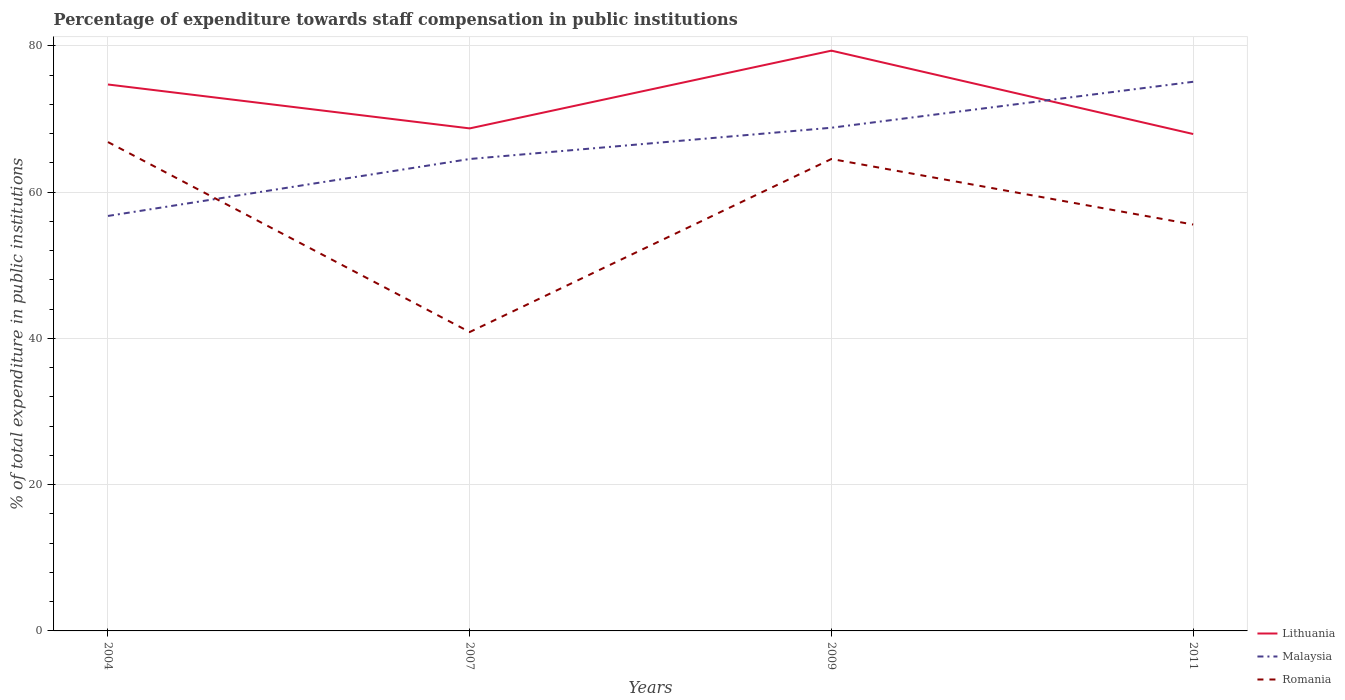How many different coloured lines are there?
Provide a succinct answer. 3. Does the line corresponding to Malaysia intersect with the line corresponding to Romania?
Ensure brevity in your answer.  Yes. Across all years, what is the maximum percentage of expenditure towards staff compensation in Malaysia?
Your answer should be very brief. 56.75. In which year was the percentage of expenditure towards staff compensation in Malaysia maximum?
Make the answer very short. 2004. What is the total percentage of expenditure towards staff compensation in Lithuania in the graph?
Offer a very short reply. -10.63. What is the difference between the highest and the second highest percentage of expenditure towards staff compensation in Lithuania?
Make the answer very short. 11.4. Is the percentage of expenditure towards staff compensation in Romania strictly greater than the percentage of expenditure towards staff compensation in Malaysia over the years?
Your answer should be very brief. No. How many lines are there?
Give a very brief answer. 3. Does the graph contain any zero values?
Make the answer very short. No. How many legend labels are there?
Your answer should be very brief. 3. What is the title of the graph?
Make the answer very short. Percentage of expenditure towards staff compensation in public institutions. What is the label or title of the X-axis?
Your answer should be very brief. Years. What is the label or title of the Y-axis?
Ensure brevity in your answer.  % of total expenditure in public institutions. What is the % of total expenditure in public institutions of Lithuania in 2004?
Your answer should be very brief. 74.73. What is the % of total expenditure in public institutions of Malaysia in 2004?
Ensure brevity in your answer.  56.75. What is the % of total expenditure in public institutions of Romania in 2004?
Make the answer very short. 66.86. What is the % of total expenditure in public institutions in Lithuania in 2007?
Your answer should be compact. 68.72. What is the % of total expenditure in public institutions of Malaysia in 2007?
Offer a very short reply. 64.54. What is the % of total expenditure in public institutions of Romania in 2007?
Keep it short and to the point. 40.88. What is the % of total expenditure in public institutions in Lithuania in 2009?
Give a very brief answer. 79.36. What is the % of total expenditure in public institutions of Malaysia in 2009?
Offer a terse response. 68.82. What is the % of total expenditure in public institutions of Romania in 2009?
Give a very brief answer. 64.54. What is the % of total expenditure in public institutions of Lithuania in 2011?
Give a very brief answer. 67.96. What is the % of total expenditure in public institutions in Malaysia in 2011?
Offer a terse response. 75.1. What is the % of total expenditure in public institutions in Romania in 2011?
Make the answer very short. 55.58. Across all years, what is the maximum % of total expenditure in public institutions of Lithuania?
Provide a succinct answer. 79.36. Across all years, what is the maximum % of total expenditure in public institutions in Malaysia?
Make the answer very short. 75.1. Across all years, what is the maximum % of total expenditure in public institutions in Romania?
Offer a very short reply. 66.86. Across all years, what is the minimum % of total expenditure in public institutions in Lithuania?
Make the answer very short. 67.96. Across all years, what is the minimum % of total expenditure in public institutions of Malaysia?
Your response must be concise. 56.75. Across all years, what is the minimum % of total expenditure in public institutions in Romania?
Ensure brevity in your answer.  40.88. What is the total % of total expenditure in public institutions in Lithuania in the graph?
Ensure brevity in your answer.  290.77. What is the total % of total expenditure in public institutions in Malaysia in the graph?
Keep it short and to the point. 265.21. What is the total % of total expenditure in public institutions of Romania in the graph?
Your answer should be very brief. 227.85. What is the difference between the % of total expenditure in public institutions in Lithuania in 2004 and that in 2007?
Keep it short and to the point. 6.01. What is the difference between the % of total expenditure in public institutions in Malaysia in 2004 and that in 2007?
Ensure brevity in your answer.  -7.79. What is the difference between the % of total expenditure in public institutions of Romania in 2004 and that in 2007?
Provide a short and direct response. 25.98. What is the difference between the % of total expenditure in public institutions in Lithuania in 2004 and that in 2009?
Your answer should be compact. -4.63. What is the difference between the % of total expenditure in public institutions in Malaysia in 2004 and that in 2009?
Provide a short and direct response. -12.06. What is the difference between the % of total expenditure in public institutions in Romania in 2004 and that in 2009?
Provide a succinct answer. 2.31. What is the difference between the % of total expenditure in public institutions in Lithuania in 2004 and that in 2011?
Give a very brief answer. 6.77. What is the difference between the % of total expenditure in public institutions of Malaysia in 2004 and that in 2011?
Your response must be concise. -18.35. What is the difference between the % of total expenditure in public institutions of Romania in 2004 and that in 2011?
Your answer should be very brief. 11.28. What is the difference between the % of total expenditure in public institutions in Lithuania in 2007 and that in 2009?
Your answer should be compact. -10.63. What is the difference between the % of total expenditure in public institutions of Malaysia in 2007 and that in 2009?
Make the answer very short. -4.28. What is the difference between the % of total expenditure in public institutions of Romania in 2007 and that in 2009?
Make the answer very short. -23.67. What is the difference between the % of total expenditure in public institutions in Lithuania in 2007 and that in 2011?
Give a very brief answer. 0.77. What is the difference between the % of total expenditure in public institutions in Malaysia in 2007 and that in 2011?
Ensure brevity in your answer.  -10.56. What is the difference between the % of total expenditure in public institutions in Romania in 2007 and that in 2011?
Ensure brevity in your answer.  -14.7. What is the difference between the % of total expenditure in public institutions of Lithuania in 2009 and that in 2011?
Your response must be concise. 11.4. What is the difference between the % of total expenditure in public institutions of Malaysia in 2009 and that in 2011?
Offer a terse response. -6.29. What is the difference between the % of total expenditure in public institutions in Romania in 2009 and that in 2011?
Your response must be concise. 8.97. What is the difference between the % of total expenditure in public institutions of Lithuania in 2004 and the % of total expenditure in public institutions of Malaysia in 2007?
Keep it short and to the point. 10.19. What is the difference between the % of total expenditure in public institutions in Lithuania in 2004 and the % of total expenditure in public institutions in Romania in 2007?
Provide a short and direct response. 33.85. What is the difference between the % of total expenditure in public institutions of Malaysia in 2004 and the % of total expenditure in public institutions of Romania in 2007?
Make the answer very short. 15.87. What is the difference between the % of total expenditure in public institutions of Lithuania in 2004 and the % of total expenditure in public institutions of Malaysia in 2009?
Offer a terse response. 5.91. What is the difference between the % of total expenditure in public institutions of Lithuania in 2004 and the % of total expenditure in public institutions of Romania in 2009?
Offer a terse response. 10.19. What is the difference between the % of total expenditure in public institutions of Malaysia in 2004 and the % of total expenditure in public institutions of Romania in 2009?
Provide a succinct answer. -7.79. What is the difference between the % of total expenditure in public institutions in Lithuania in 2004 and the % of total expenditure in public institutions in Malaysia in 2011?
Provide a short and direct response. -0.37. What is the difference between the % of total expenditure in public institutions of Lithuania in 2004 and the % of total expenditure in public institutions of Romania in 2011?
Offer a terse response. 19.15. What is the difference between the % of total expenditure in public institutions of Malaysia in 2004 and the % of total expenditure in public institutions of Romania in 2011?
Give a very brief answer. 1.18. What is the difference between the % of total expenditure in public institutions of Lithuania in 2007 and the % of total expenditure in public institutions of Malaysia in 2009?
Your answer should be compact. -0.09. What is the difference between the % of total expenditure in public institutions in Lithuania in 2007 and the % of total expenditure in public institutions in Romania in 2009?
Ensure brevity in your answer.  4.18. What is the difference between the % of total expenditure in public institutions in Malaysia in 2007 and the % of total expenditure in public institutions in Romania in 2009?
Provide a succinct answer. -0. What is the difference between the % of total expenditure in public institutions in Lithuania in 2007 and the % of total expenditure in public institutions in Malaysia in 2011?
Give a very brief answer. -6.38. What is the difference between the % of total expenditure in public institutions of Lithuania in 2007 and the % of total expenditure in public institutions of Romania in 2011?
Provide a short and direct response. 13.15. What is the difference between the % of total expenditure in public institutions in Malaysia in 2007 and the % of total expenditure in public institutions in Romania in 2011?
Offer a very short reply. 8.96. What is the difference between the % of total expenditure in public institutions in Lithuania in 2009 and the % of total expenditure in public institutions in Malaysia in 2011?
Your response must be concise. 4.26. What is the difference between the % of total expenditure in public institutions of Lithuania in 2009 and the % of total expenditure in public institutions of Romania in 2011?
Make the answer very short. 23.78. What is the difference between the % of total expenditure in public institutions of Malaysia in 2009 and the % of total expenditure in public institutions of Romania in 2011?
Your answer should be very brief. 13.24. What is the average % of total expenditure in public institutions in Lithuania per year?
Keep it short and to the point. 72.69. What is the average % of total expenditure in public institutions of Malaysia per year?
Your response must be concise. 66.3. What is the average % of total expenditure in public institutions of Romania per year?
Offer a terse response. 56.96. In the year 2004, what is the difference between the % of total expenditure in public institutions in Lithuania and % of total expenditure in public institutions in Malaysia?
Offer a very short reply. 17.98. In the year 2004, what is the difference between the % of total expenditure in public institutions in Lithuania and % of total expenditure in public institutions in Romania?
Provide a short and direct response. 7.87. In the year 2004, what is the difference between the % of total expenditure in public institutions in Malaysia and % of total expenditure in public institutions in Romania?
Keep it short and to the point. -10.11. In the year 2007, what is the difference between the % of total expenditure in public institutions in Lithuania and % of total expenditure in public institutions in Malaysia?
Your answer should be very brief. 4.18. In the year 2007, what is the difference between the % of total expenditure in public institutions in Lithuania and % of total expenditure in public institutions in Romania?
Offer a terse response. 27.85. In the year 2007, what is the difference between the % of total expenditure in public institutions of Malaysia and % of total expenditure in public institutions of Romania?
Your answer should be compact. 23.66. In the year 2009, what is the difference between the % of total expenditure in public institutions in Lithuania and % of total expenditure in public institutions in Malaysia?
Your answer should be compact. 10.54. In the year 2009, what is the difference between the % of total expenditure in public institutions of Lithuania and % of total expenditure in public institutions of Romania?
Ensure brevity in your answer.  14.82. In the year 2009, what is the difference between the % of total expenditure in public institutions of Malaysia and % of total expenditure in public institutions of Romania?
Give a very brief answer. 4.27. In the year 2011, what is the difference between the % of total expenditure in public institutions of Lithuania and % of total expenditure in public institutions of Malaysia?
Your answer should be compact. -7.15. In the year 2011, what is the difference between the % of total expenditure in public institutions of Lithuania and % of total expenditure in public institutions of Romania?
Make the answer very short. 12.38. In the year 2011, what is the difference between the % of total expenditure in public institutions in Malaysia and % of total expenditure in public institutions in Romania?
Provide a succinct answer. 19.53. What is the ratio of the % of total expenditure in public institutions in Lithuania in 2004 to that in 2007?
Your answer should be compact. 1.09. What is the ratio of the % of total expenditure in public institutions of Malaysia in 2004 to that in 2007?
Provide a short and direct response. 0.88. What is the ratio of the % of total expenditure in public institutions of Romania in 2004 to that in 2007?
Your answer should be very brief. 1.64. What is the ratio of the % of total expenditure in public institutions of Lithuania in 2004 to that in 2009?
Offer a very short reply. 0.94. What is the ratio of the % of total expenditure in public institutions in Malaysia in 2004 to that in 2009?
Your answer should be compact. 0.82. What is the ratio of the % of total expenditure in public institutions in Romania in 2004 to that in 2009?
Keep it short and to the point. 1.04. What is the ratio of the % of total expenditure in public institutions in Lithuania in 2004 to that in 2011?
Offer a very short reply. 1.1. What is the ratio of the % of total expenditure in public institutions of Malaysia in 2004 to that in 2011?
Make the answer very short. 0.76. What is the ratio of the % of total expenditure in public institutions in Romania in 2004 to that in 2011?
Provide a short and direct response. 1.2. What is the ratio of the % of total expenditure in public institutions in Lithuania in 2007 to that in 2009?
Provide a succinct answer. 0.87. What is the ratio of the % of total expenditure in public institutions of Malaysia in 2007 to that in 2009?
Offer a terse response. 0.94. What is the ratio of the % of total expenditure in public institutions of Romania in 2007 to that in 2009?
Make the answer very short. 0.63. What is the ratio of the % of total expenditure in public institutions of Lithuania in 2007 to that in 2011?
Provide a short and direct response. 1.01. What is the ratio of the % of total expenditure in public institutions of Malaysia in 2007 to that in 2011?
Provide a short and direct response. 0.86. What is the ratio of the % of total expenditure in public institutions of Romania in 2007 to that in 2011?
Ensure brevity in your answer.  0.74. What is the ratio of the % of total expenditure in public institutions of Lithuania in 2009 to that in 2011?
Your answer should be very brief. 1.17. What is the ratio of the % of total expenditure in public institutions of Malaysia in 2009 to that in 2011?
Provide a short and direct response. 0.92. What is the ratio of the % of total expenditure in public institutions of Romania in 2009 to that in 2011?
Your answer should be compact. 1.16. What is the difference between the highest and the second highest % of total expenditure in public institutions in Lithuania?
Ensure brevity in your answer.  4.63. What is the difference between the highest and the second highest % of total expenditure in public institutions of Malaysia?
Make the answer very short. 6.29. What is the difference between the highest and the second highest % of total expenditure in public institutions in Romania?
Ensure brevity in your answer.  2.31. What is the difference between the highest and the lowest % of total expenditure in public institutions in Lithuania?
Offer a very short reply. 11.4. What is the difference between the highest and the lowest % of total expenditure in public institutions of Malaysia?
Keep it short and to the point. 18.35. What is the difference between the highest and the lowest % of total expenditure in public institutions in Romania?
Your answer should be very brief. 25.98. 